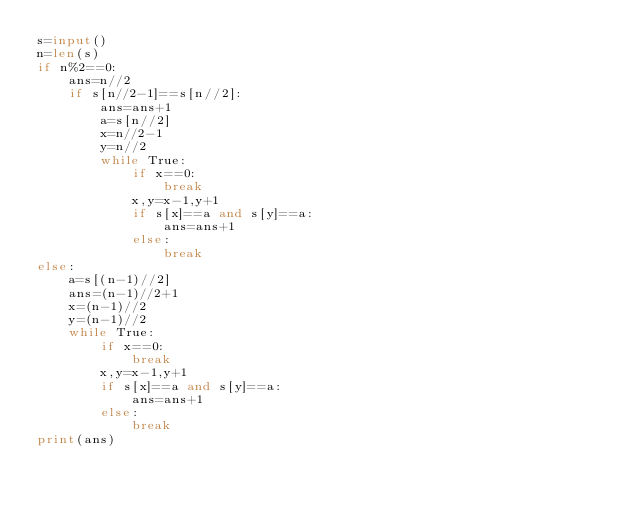Convert code to text. <code><loc_0><loc_0><loc_500><loc_500><_Python_>s=input()
n=len(s)
if n%2==0:
    ans=n//2
    if s[n//2-1]==s[n//2]:
        ans=ans+1
        a=s[n//2]
        x=n//2-1
        y=n//2
        while True:
            if x==0:
                break
            x,y=x-1,y+1
            if s[x]==a and s[y]==a:
                ans=ans+1
            else:
                break
else:
    a=s[(n-1)//2]
    ans=(n-1)//2+1
    x=(n-1)//2
    y=(n-1)//2
    while True:
        if x==0:
            break
        x,y=x-1,y+1
        if s[x]==a and s[y]==a:
            ans=ans+1
        else:
            break
print(ans)
</code> 